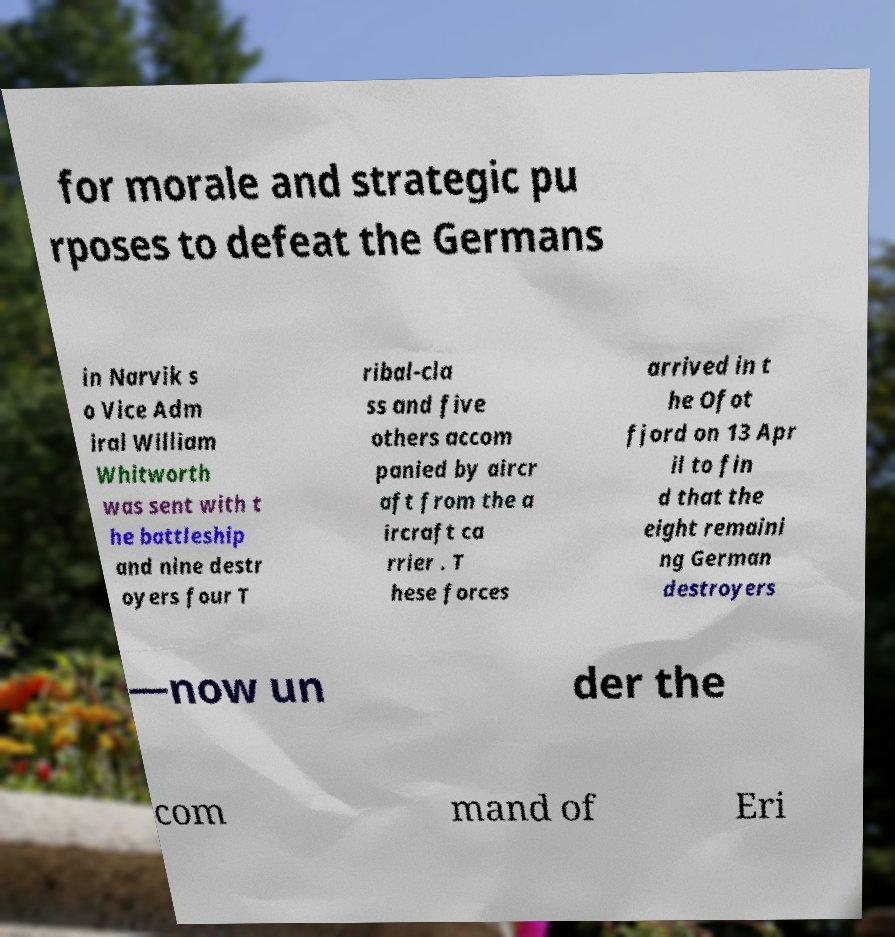Could you extract and type out the text from this image? for morale and strategic pu rposes to defeat the Germans in Narvik s o Vice Adm iral William Whitworth was sent with t he battleship and nine destr oyers four T ribal-cla ss and five others accom panied by aircr aft from the a ircraft ca rrier . T hese forces arrived in t he Ofot fjord on 13 Apr il to fin d that the eight remaini ng German destroyers —now un der the com mand of Eri 